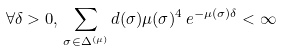Convert formula to latex. <formula><loc_0><loc_0><loc_500><loc_500>\forall \delta > 0 , \, \sum _ { \sigma \in \Delta ^ { ( \mu ) } } d ( \sigma ) \mu ( \sigma ) ^ { 4 } \, e ^ { - \mu ( \sigma ) \delta } < \infty</formula> 